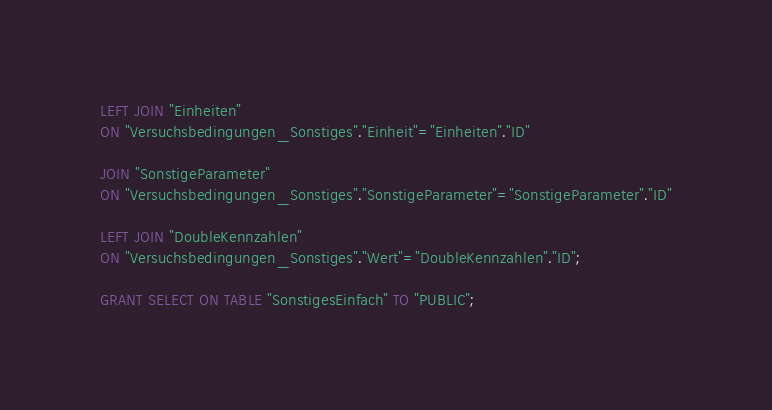Convert code to text. <code><loc_0><loc_0><loc_500><loc_500><_SQL_>
LEFT JOIN "Einheiten"
ON "Versuchsbedingungen_Sonstiges"."Einheit"="Einheiten"."ID"

JOIN "SonstigeParameter"
ON "Versuchsbedingungen_Sonstiges"."SonstigeParameter"="SonstigeParameter"."ID"

LEFT JOIN "DoubleKennzahlen"
ON "Versuchsbedingungen_Sonstiges"."Wert"="DoubleKennzahlen"."ID";

GRANT SELECT ON TABLE "SonstigesEinfach" TO "PUBLIC";</code> 